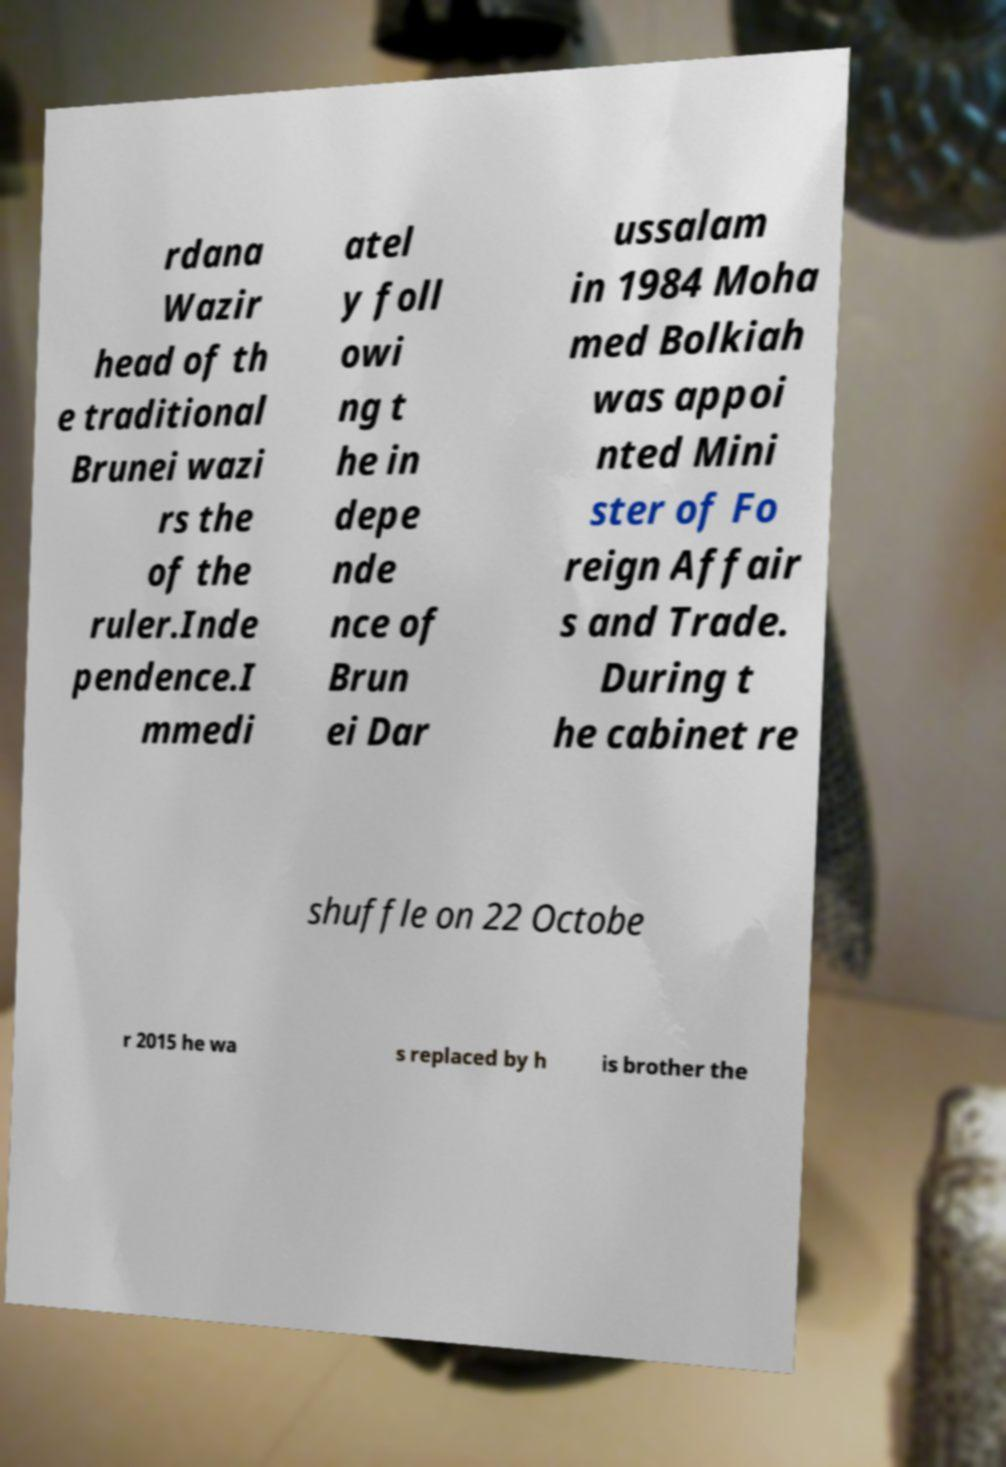I need the written content from this picture converted into text. Can you do that? rdana Wazir head of th e traditional Brunei wazi rs the of the ruler.Inde pendence.I mmedi atel y foll owi ng t he in depe nde nce of Brun ei Dar ussalam in 1984 Moha med Bolkiah was appoi nted Mini ster of Fo reign Affair s and Trade. During t he cabinet re shuffle on 22 Octobe r 2015 he wa s replaced by h is brother the 